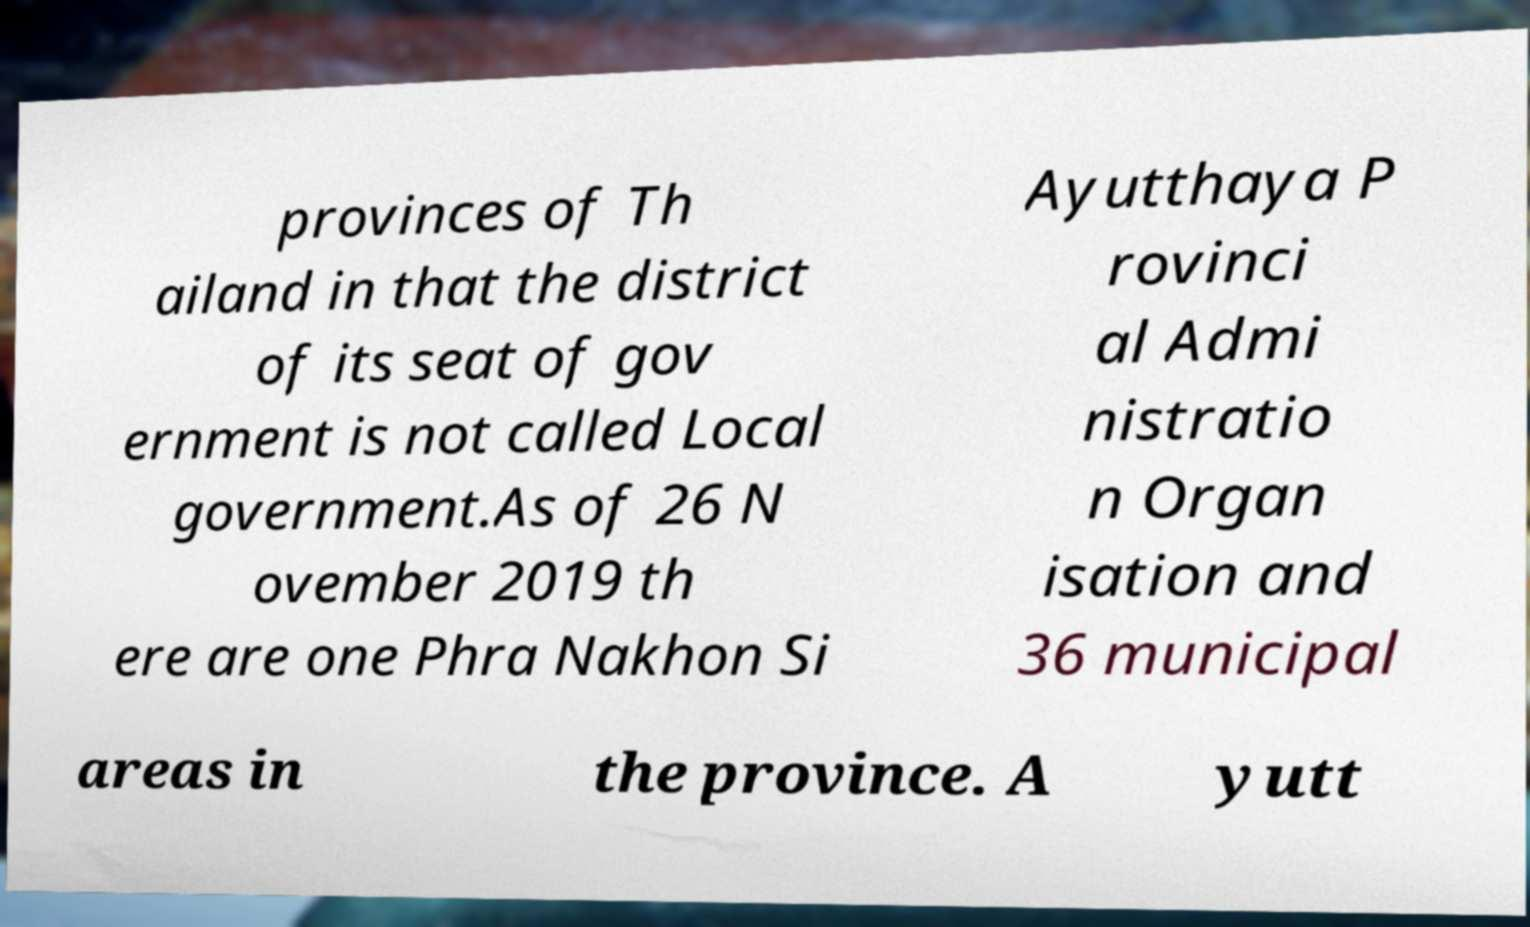Can you accurately transcribe the text from the provided image for me? provinces of Th ailand in that the district of its seat of gov ernment is not called Local government.As of 26 N ovember 2019 th ere are one Phra Nakhon Si Ayutthaya P rovinci al Admi nistratio n Organ isation and 36 municipal areas in the province. A yutt 